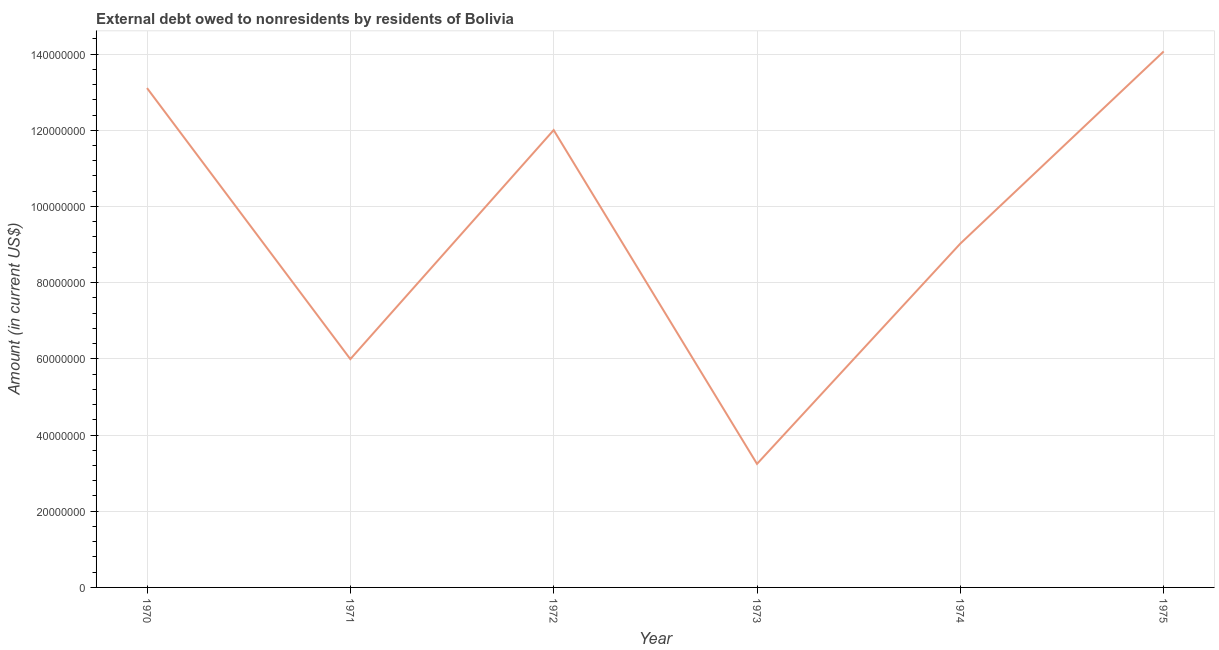What is the debt in 1973?
Offer a terse response. 3.24e+07. Across all years, what is the maximum debt?
Make the answer very short. 1.41e+08. Across all years, what is the minimum debt?
Your answer should be very brief. 3.24e+07. In which year was the debt maximum?
Provide a succinct answer. 1975. In which year was the debt minimum?
Provide a succinct answer. 1973. What is the sum of the debt?
Offer a very short reply. 5.74e+08. What is the difference between the debt in 1974 and 1975?
Offer a terse response. -5.04e+07. What is the average debt per year?
Make the answer very short. 9.57e+07. What is the median debt?
Ensure brevity in your answer.  1.05e+08. In how many years, is the debt greater than 56000000 US$?
Provide a short and direct response. 5. Do a majority of the years between 1974 and 1970 (inclusive) have debt greater than 76000000 US$?
Your answer should be compact. Yes. What is the ratio of the debt in 1972 to that in 1973?
Ensure brevity in your answer.  3.7. Is the debt in 1971 less than that in 1974?
Provide a short and direct response. Yes. Is the difference between the debt in 1971 and 1975 greater than the difference between any two years?
Make the answer very short. No. What is the difference between the highest and the second highest debt?
Your answer should be compact. 9.61e+06. What is the difference between the highest and the lowest debt?
Offer a terse response. 1.08e+08. In how many years, is the debt greater than the average debt taken over all years?
Keep it short and to the point. 3. Does the debt monotonically increase over the years?
Keep it short and to the point. No. Does the graph contain grids?
Offer a terse response. Yes. What is the title of the graph?
Make the answer very short. External debt owed to nonresidents by residents of Bolivia. What is the label or title of the X-axis?
Provide a succinct answer. Year. What is the label or title of the Y-axis?
Provide a succinct answer. Amount (in current US$). What is the Amount (in current US$) in 1970?
Ensure brevity in your answer.  1.31e+08. What is the Amount (in current US$) of 1971?
Your answer should be very brief. 5.99e+07. What is the Amount (in current US$) in 1972?
Your response must be concise. 1.20e+08. What is the Amount (in current US$) of 1973?
Your answer should be compact. 3.24e+07. What is the Amount (in current US$) in 1974?
Make the answer very short. 9.02e+07. What is the Amount (in current US$) in 1975?
Offer a very short reply. 1.41e+08. What is the difference between the Amount (in current US$) in 1970 and 1971?
Provide a short and direct response. 7.11e+07. What is the difference between the Amount (in current US$) in 1970 and 1972?
Your answer should be very brief. 1.10e+07. What is the difference between the Amount (in current US$) in 1970 and 1973?
Ensure brevity in your answer.  9.87e+07. What is the difference between the Amount (in current US$) in 1970 and 1974?
Provide a succinct answer. 4.08e+07. What is the difference between the Amount (in current US$) in 1970 and 1975?
Keep it short and to the point. -9.61e+06. What is the difference between the Amount (in current US$) in 1971 and 1972?
Keep it short and to the point. -6.01e+07. What is the difference between the Amount (in current US$) in 1971 and 1973?
Your response must be concise. 2.75e+07. What is the difference between the Amount (in current US$) in 1971 and 1974?
Your response must be concise. -3.03e+07. What is the difference between the Amount (in current US$) in 1971 and 1975?
Your response must be concise. -8.08e+07. What is the difference between the Amount (in current US$) in 1972 and 1973?
Provide a short and direct response. 8.76e+07. What is the difference between the Amount (in current US$) in 1972 and 1974?
Provide a succinct answer. 2.98e+07. What is the difference between the Amount (in current US$) in 1972 and 1975?
Give a very brief answer. -2.06e+07. What is the difference between the Amount (in current US$) in 1973 and 1974?
Provide a succinct answer. -5.78e+07. What is the difference between the Amount (in current US$) in 1973 and 1975?
Give a very brief answer. -1.08e+08. What is the difference between the Amount (in current US$) in 1974 and 1975?
Provide a short and direct response. -5.04e+07. What is the ratio of the Amount (in current US$) in 1970 to that in 1971?
Ensure brevity in your answer.  2.19. What is the ratio of the Amount (in current US$) in 1970 to that in 1972?
Give a very brief answer. 1.09. What is the ratio of the Amount (in current US$) in 1970 to that in 1973?
Make the answer very short. 4.04. What is the ratio of the Amount (in current US$) in 1970 to that in 1974?
Your response must be concise. 1.45. What is the ratio of the Amount (in current US$) in 1970 to that in 1975?
Make the answer very short. 0.93. What is the ratio of the Amount (in current US$) in 1971 to that in 1972?
Keep it short and to the point. 0.5. What is the ratio of the Amount (in current US$) in 1971 to that in 1973?
Provide a succinct answer. 1.85. What is the ratio of the Amount (in current US$) in 1971 to that in 1974?
Your answer should be very brief. 0.66. What is the ratio of the Amount (in current US$) in 1971 to that in 1975?
Give a very brief answer. 0.43. What is the ratio of the Amount (in current US$) in 1972 to that in 1973?
Provide a succinct answer. 3.7. What is the ratio of the Amount (in current US$) in 1972 to that in 1974?
Provide a short and direct response. 1.33. What is the ratio of the Amount (in current US$) in 1972 to that in 1975?
Your answer should be very brief. 0.85. What is the ratio of the Amount (in current US$) in 1973 to that in 1974?
Keep it short and to the point. 0.36. What is the ratio of the Amount (in current US$) in 1973 to that in 1975?
Keep it short and to the point. 0.23. What is the ratio of the Amount (in current US$) in 1974 to that in 1975?
Keep it short and to the point. 0.64. 